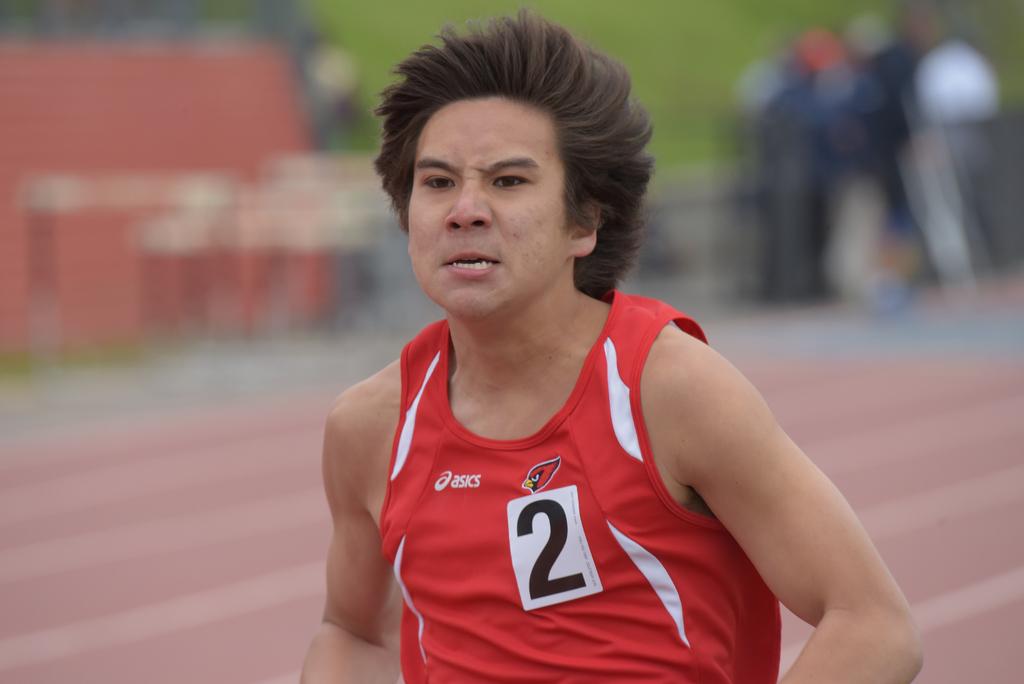What is the tag number of this runner?
Your answer should be very brief. 2. What is the brand on the jersey?
Offer a terse response. Asics. 